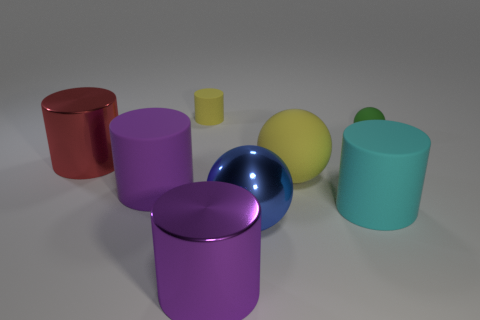Can you describe the objects in the image and their colors? Certainly! The image displays a collection of geometric solids. There is a magenta cylinder, a red cylinder, a violet cylinder, a teal cylinder, a yellow-green shorter cylinder, and a blue metallic sphere. The color distribution is quite vibrant and covers a spectrum from warmer tones, like red, to cooler shades, such as blue and teal. 